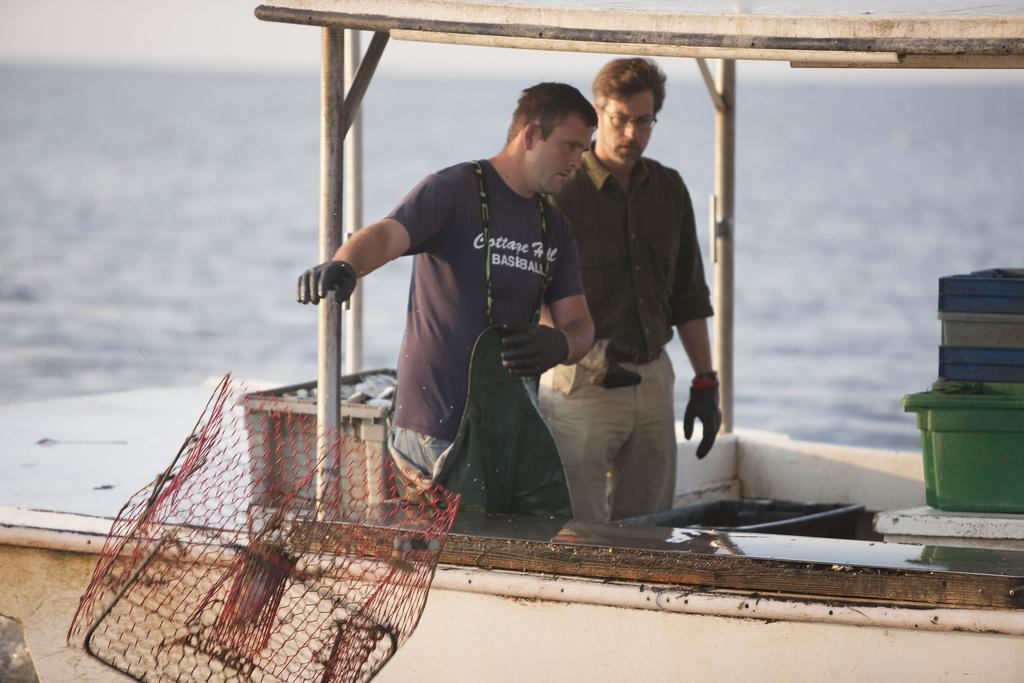What is the main subject of the image? The main subject of the image is a boat in the water. Are there any people on the boat? Yes, there are two persons on the boat. What object is present in the image that might be used for fishing? There is a net present in the image. What type of container can be seen in the image? There are tubs visible in the image. Can you see a receipt for the boat in the image? No, there is no receipt present in the image. How many wings are visible on the boat in the image? There are no wings visible on the boat in the image. 